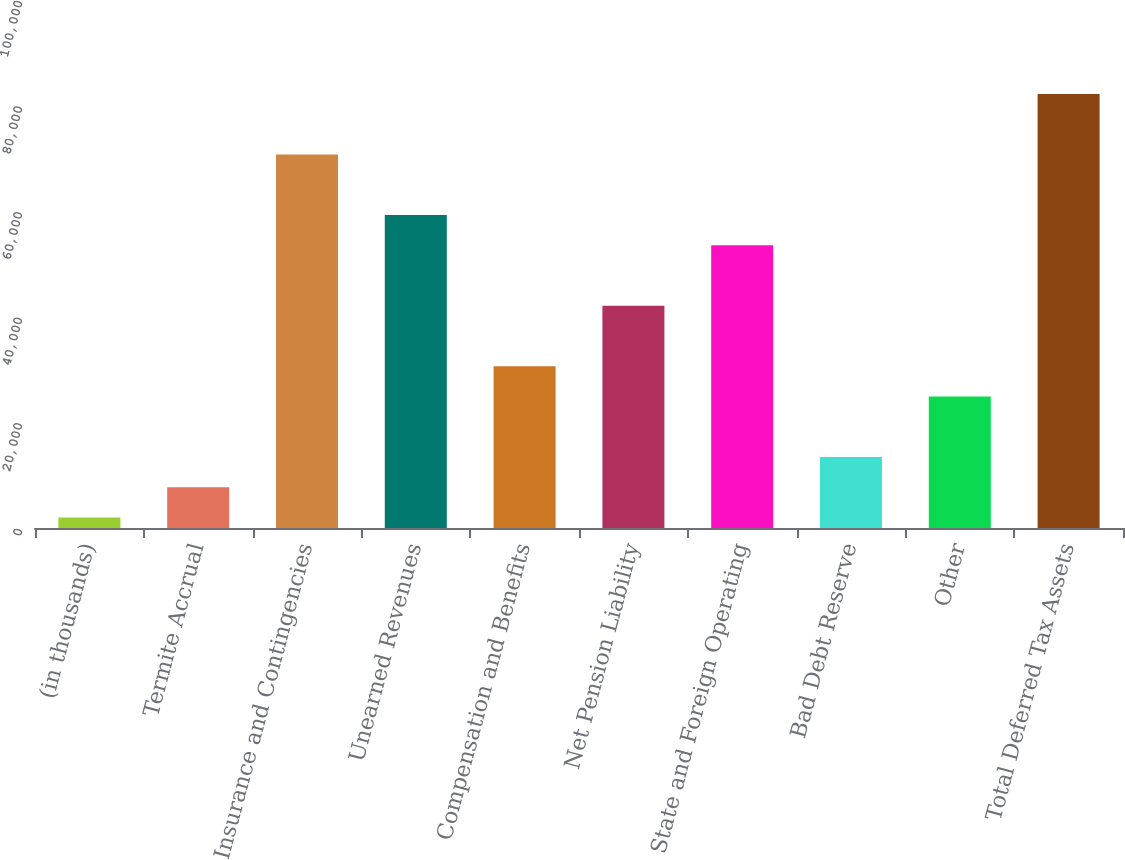Convert chart. <chart><loc_0><loc_0><loc_500><loc_500><bar_chart><fcel>(in thousands)<fcel>Termite Accrual<fcel>Insurance and Contingencies<fcel>Unearned Revenues<fcel>Compensation and Benefits<fcel>Net Pension Liability<fcel>State and Foreign Operating<fcel>Bad Debt Reserve<fcel>Other<fcel>Total Deferred Tax Assets<nl><fcel>2009<fcel>7738.2<fcel>70759.4<fcel>59301<fcel>30655<fcel>42113.4<fcel>53571.8<fcel>13467.4<fcel>24925.8<fcel>82217.8<nl></chart> 